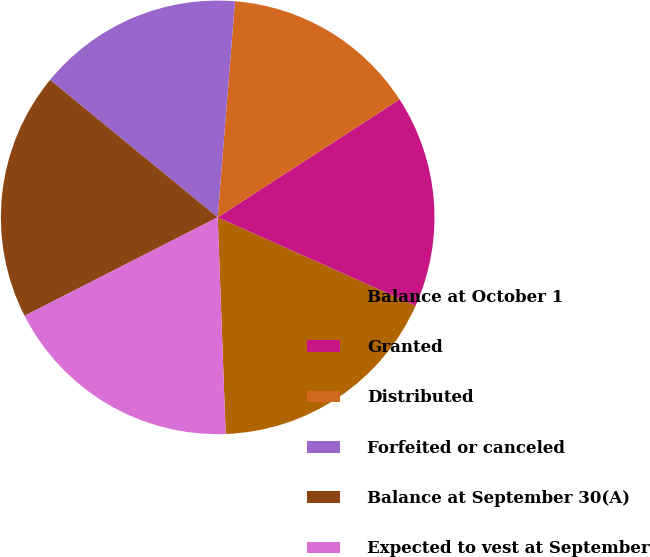Convert chart to OTSL. <chart><loc_0><loc_0><loc_500><loc_500><pie_chart><fcel>Balance at October 1<fcel>Granted<fcel>Distributed<fcel>Forfeited or canceled<fcel>Balance at September 30(A)<fcel>Expected to vest at September<nl><fcel>17.73%<fcel>15.84%<fcel>14.57%<fcel>15.34%<fcel>18.44%<fcel>18.08%<nl></chart> 